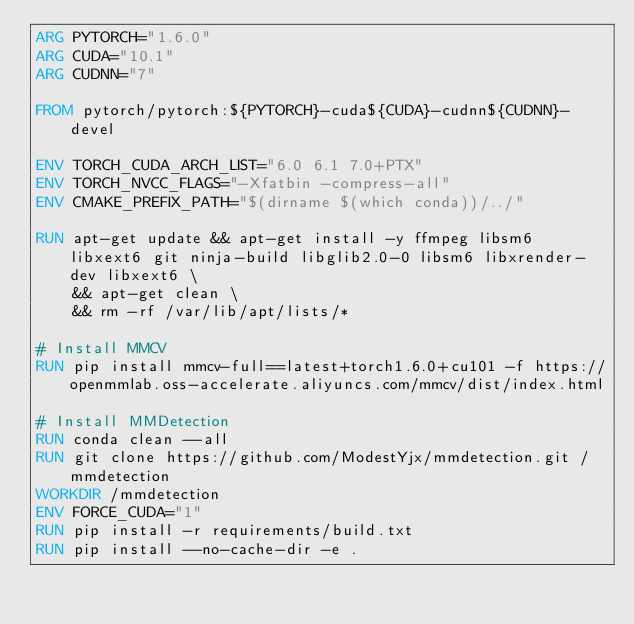<code> <loc_0><loc_0><loc_500><loc_500><_Dockerfile_>ARG PYTORCH="1.6.0"
ARG CUDA="10.1"
ARG CUDNN="7"

FROM pytorch/pytorch:${PYTORCH}-cuda${CUDA}-cudnn${CUDNN}-devel

ENV TORCH_CUDA_ARCH_LIST="6.0 6.1 7.0+PTX"
ENV TORCH_NVCC_FLAGS="-Xfatbin -compress-all"
ENV CMAKE_PREFIX_PATH="$(dirname $(which conda))/../"

RUN apt-get update && apt-get install -y ffmpeg libsm6 libxext6 git ninja-build libglib2.0-0 libsm6 libxrender-dev libxext6 \
    && apt-get clean \
    && rm -rf /var/lib/apt/lists/*

# Install MMCV
RUN pip install mmcv-full==latest+torch1.6.0+cu101 -f https://openmmlab.oss-accelerate.aliyuncs.com/mmcv/dist/index.html

# Install MMDetection
RUN conda clean --all
RUN git clone https://github.com/ModestYjx/mmdetection.git /mmdetection
WORKDIR /mmdetection
ENV FORCE_CUDA="1"
RUN pip install -r requirements/build.txt
RUN pip install --no-cache-dir -e .
</code> 